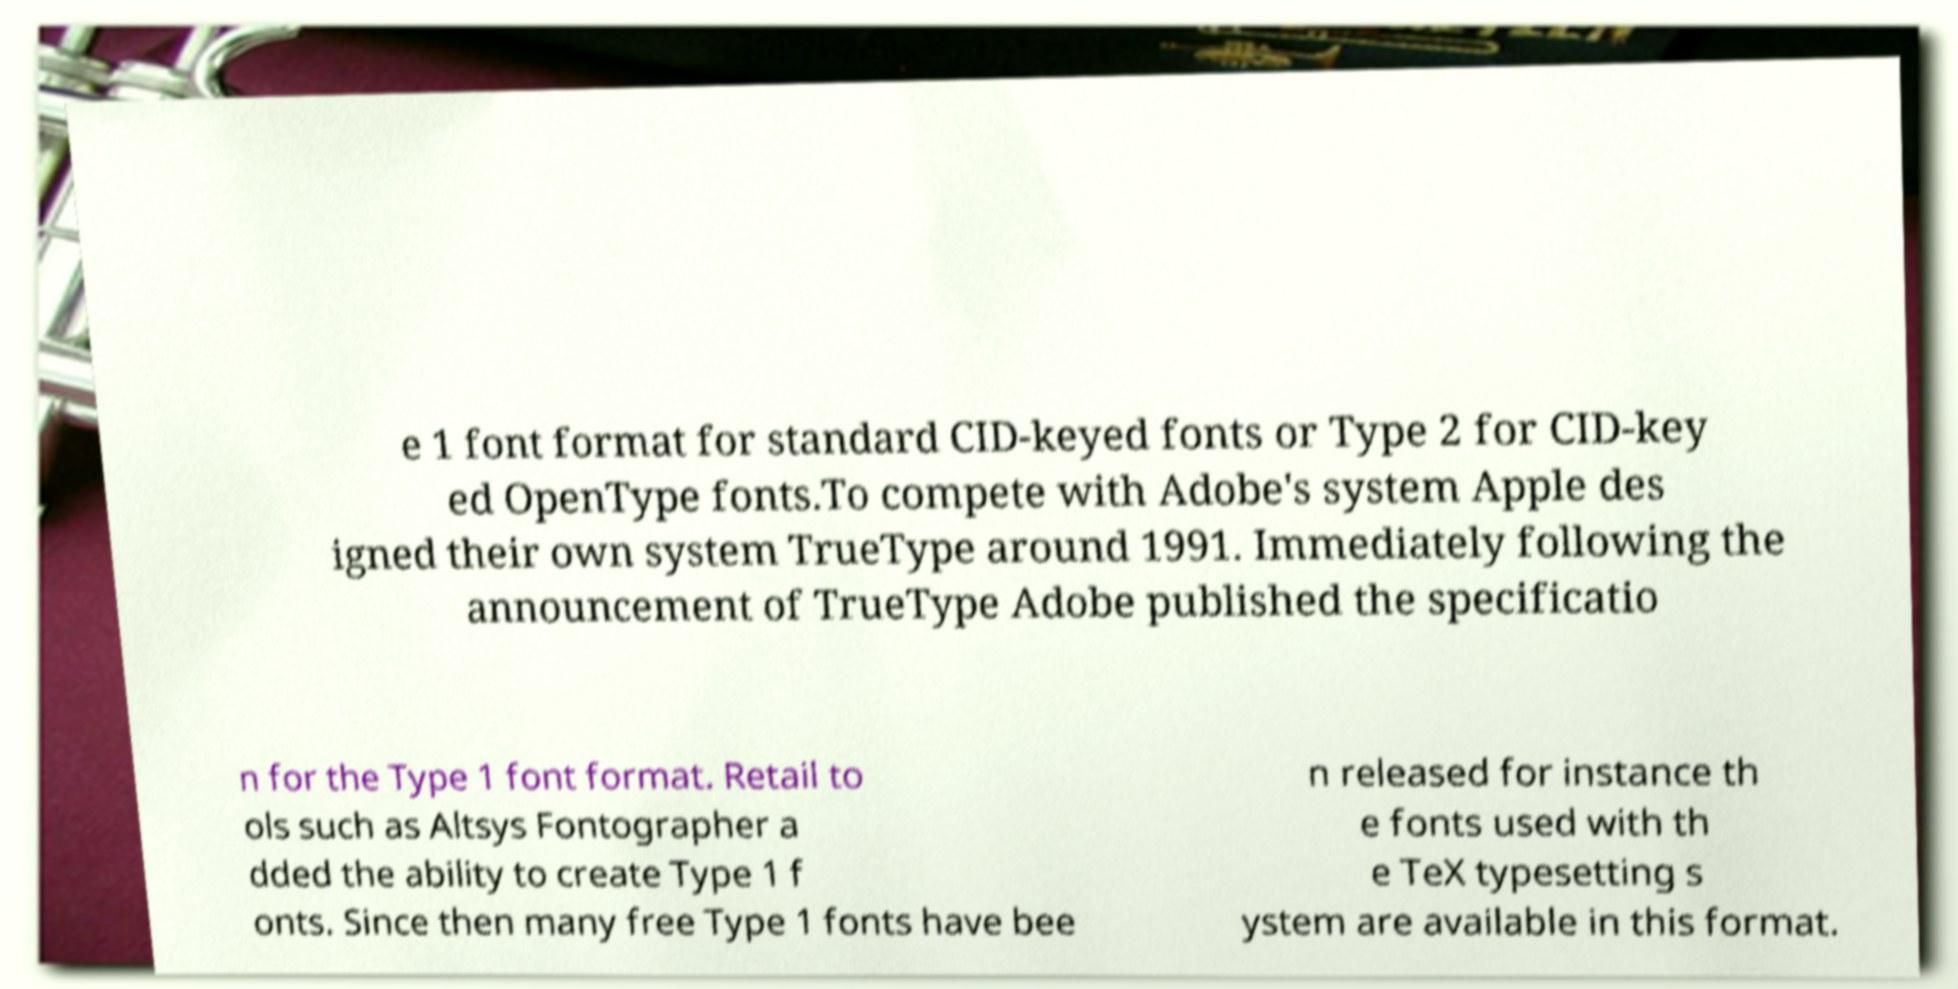What messages or text are displayed in this image? I need them in a readable, typed format. e 1 font format for standard CID-keyed fonts or Type 2 for CID-key ed OpenType fonts.To compete with Adobe's system Apple des igned their own system TrueType around 1991. Immediately following the announcement of TrueType Adobe published the specificatio n for the Type 1 font format. Retail to ols such as Altsys Fontographer a dded the ability to create Type 1 f onts. Since then many free Type 1 fonts have bee n released for instance th e fonts used with th e TeX typesetting s ystem are available in this format. 